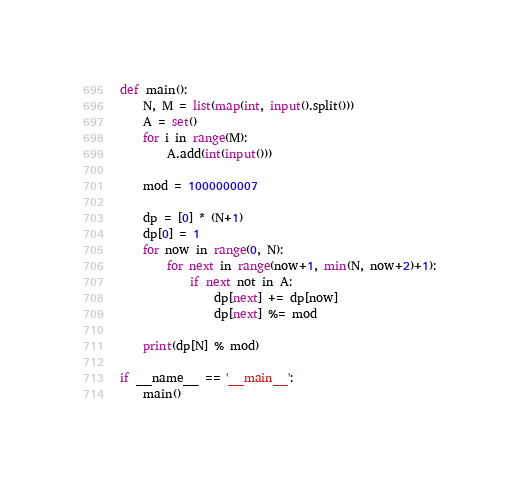<code> <loc_0><loc_0><loc_500><loc_500><_Python_>def main():
    N, M = list(map(int, input().split()))
    A = set()
    for i in range(M):
        A.add(int(input()))

    mod = 1000000007

    dp = [0] * (N+1)
    dp[0] = 1
    for now in range(0, N):
        for next in range(now+1, min(N, now+2)+1):
            if next not in A:
                dp[next] += dp[now]
                dp[next] %= mod

    print(dp[N] % mod)

if __name__ == '__main__':
    main()</code> 